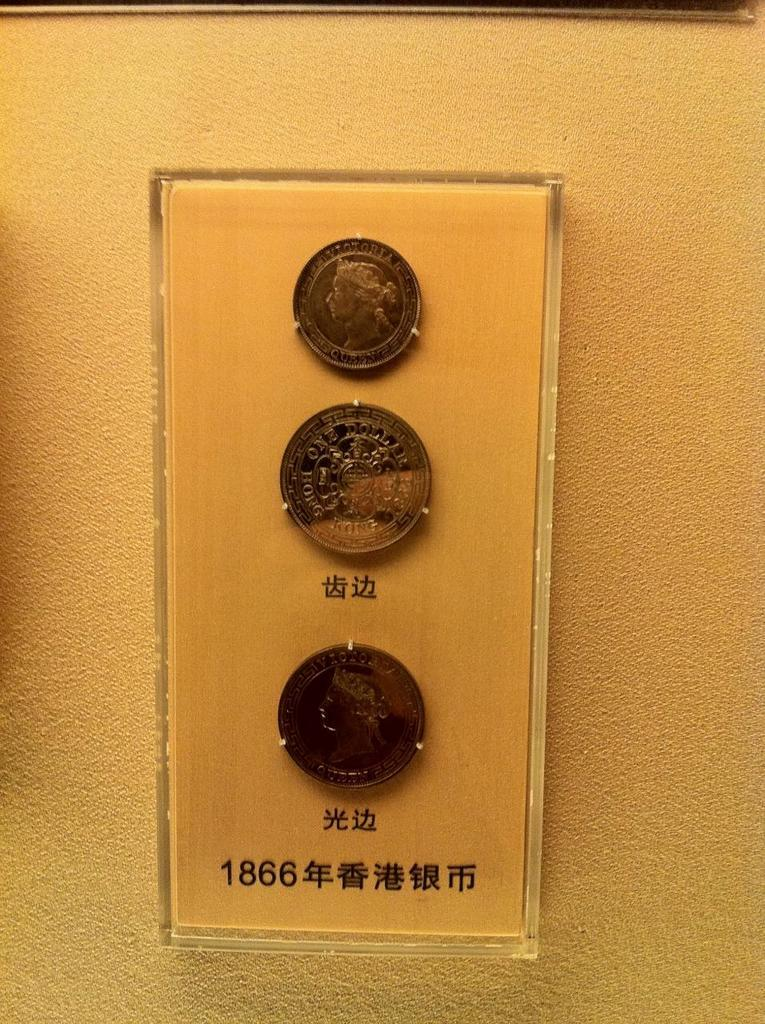Provide a one-sentence caption for the provided image. Three coins from Hong Kong with the sign 1866 are displayed in a plastic case. 